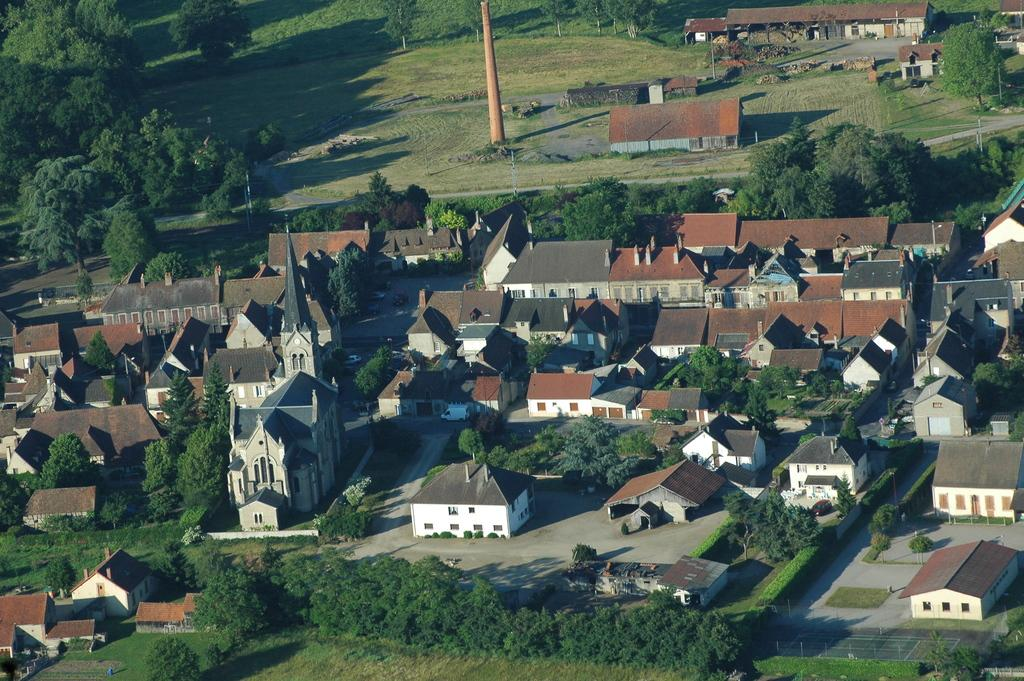What type of view is shown in the image? The image is an aerial view of a place. What structures can be seen in the image? There are houses in the image. What object is present in the image that is typically used for signaling or communication? There is a pole in the image. What type of vegetation is visible in the image? There are plants and trees in the image. Can you see a tank in the image? There is no tank present in the image. Is the horse stuck in quicksand in the image? There is no horse or quicksand present in the image. 